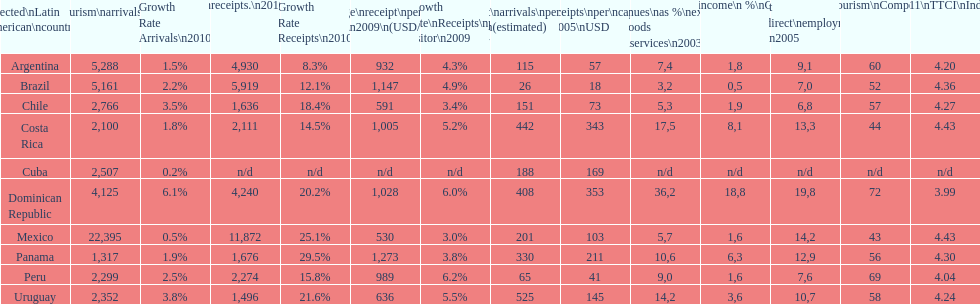Can you identify the last country displayed on this chart? Uruguay. 